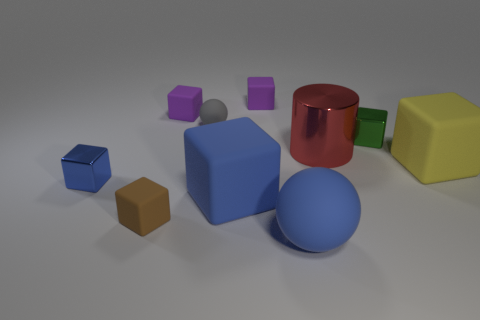There is a brown object that is the same shape as the green metal thing; what is it made of?
Offer a very short reply. Rubber. Is there any other thing that has the same material as the tiny ball?
Your answer should be very brief. Yes. Are there any big rubber cubes to the right of the yellow block?
Your response must be concise. No. What number of cubes are there?
Offer a terse response. 7. There is a big cube right of the small green object; how many matte things are in front of it?
Keep it short and to the point. 3. There is a big ball; does it have the same color as the small rubber object right of the tiny gray matte sphere?
Your answer should be compact. No. How many brown things are the same shape as the blue shiny object?
Provide a short and direct response. 1. There is a big cube that is on the left side of the large yellow rubber object; what is its material?
Keep it short and to the point. Rubber. There is a thing right of the tiny green thing; is its shape the same as the tiny brown thing?
Your answer should be compact. Yes. Are there any yellow rubber cubes that have the same size as the green shiny block?
Offer a terse response. No. 